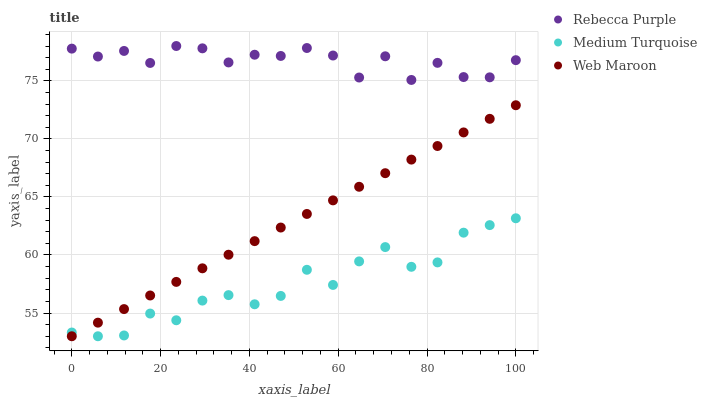Does Medium Turquoise have the minimum area under the curve?
Answer yes or no. Yes. Does Rebecca Purple have the maximum area under the curve?
Answer yes or no. Yes. Does Rebecca Purple have the minimum area under the curve?
Answer yes or no. No. Does Medium Turquoise have the maximum area under the curve?
Answer yes or no. No. Is Web Maroon the smoothest?
Answer yes or no. Yes. Is Rebecca Purple the roughest?
Answer yes or no. Yes. Is Medium Turquoise the smoothest?
Answer yes or no. No. Is Medium Turquoise the roughest?
Answer yes or no. No. Does Web Maroon have the lowest value?
Answer yes or no. Yes. Does Rebecca Purple have the lowest value?
Answer yes or no. No. Does Rebecca Purple have the highest value?
Answer yes or no. Yes. Does Medium Turquoise have the highest value?
Answer yes or no. No. Is Web Maroon less than Rebecca Purple?
Answer yes or no. Yes. Is Rebecca Purple greater than Medium Turquoise?
Answer yes or no. Yes. Does Medium Turquoise intersect Web Maroon?
Answer yes or no. Yes. Is Medium Turquoise less than Web Maroon?
Answer yes or no. No. Is Medium Turquoise greater than Web Maroon?
Answer yes or no. No. Does Web Maroon intersect Rebecca Purple?
Answer yes or no. No. 